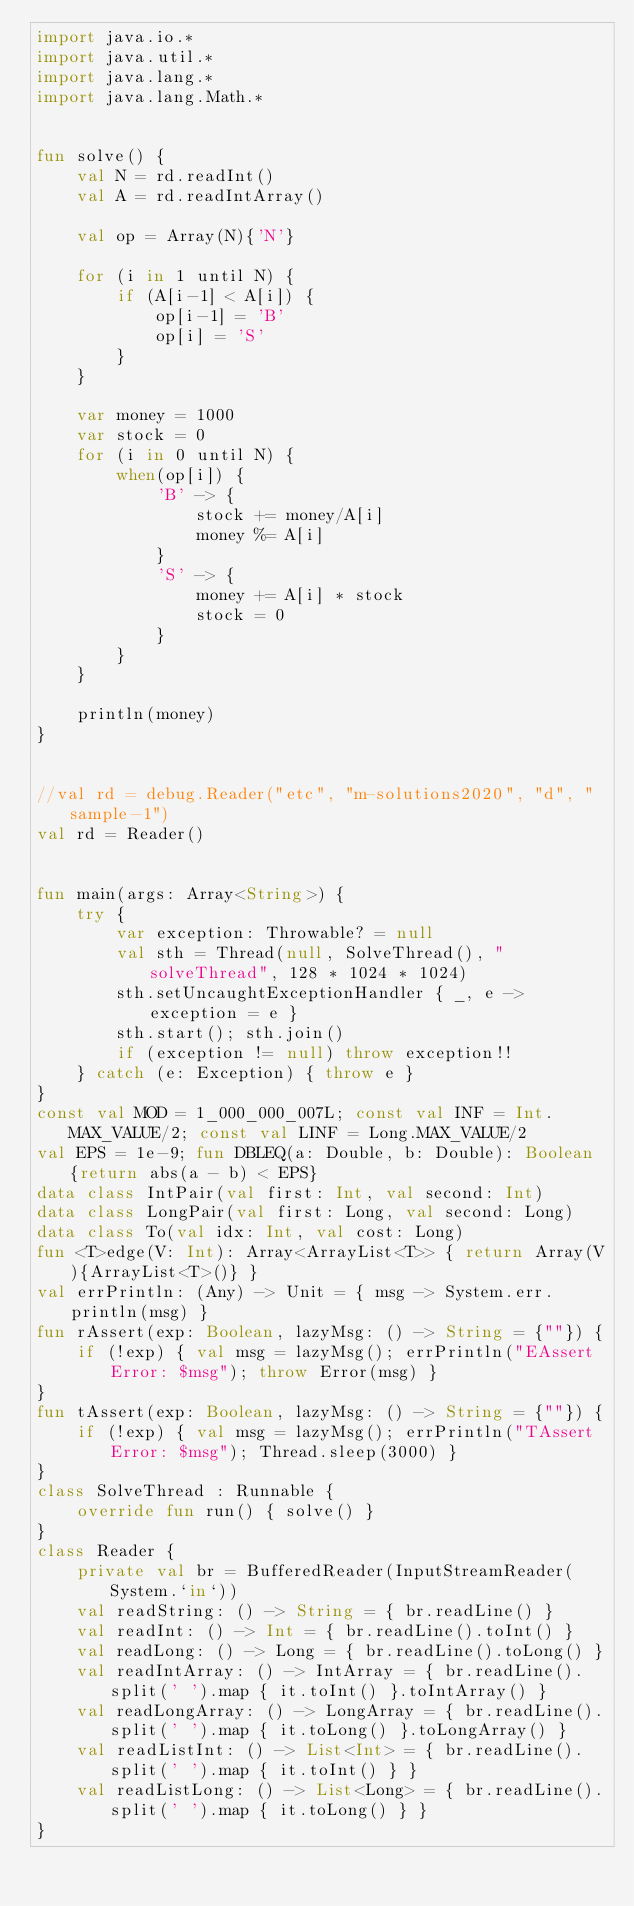<code> <loc_0><loc_0><loc_500><loc_500><_Kotlin_>import java.io.*
import java.util.*
import java.lang.*
import java.lang.Math.*


fun solve() {
    val N = rd.readInt()
    val A = rd.readIntArray()

    val op = Array(N){'N'}

    for (i in 1 until N) {
        if (A[i-1] < A[i]) {
            op[i-1] = 'B'
            op[i] = 'S'
        }
    }

    var money = 1000
    var stock = 0
    for (i in 0 until N) {
        when(op[i]) {
            'B' -> {
                stock += money/A[i]
                money %= A[i]
            }
            'S' -> {
                money += A[i] * stock
                stock = 0
            }
        }
    }

    println(money)
}


//val rd = debug.Reader("etc", "m-solutions2020", "d", "sample-1")
val rd = Reader()


fun main(args: Array<String>) {
    try {
        var exception: Throwable? = null
        val sth = Thread(null, SolveThread(), "solveThread", 128 * 1024 * 1024)
        sth.setUncaughtExceptionHandler { _, e -> exception = e }
        sth.start(); sth.join()
        if (exception != null) throw exception!!
    } catch (e: Exception) { throw e }
}
const val MOD = 1_000_000_007L; const val INF = Int.MAX_VALUE/2; const val LINF = Long.MAX_VALUE/2
val EPS = 1e-9; fun DBLEQ(a: Double, b: Double): Boolean {return abs(a - b) < EPS}
data class IntPair(val first: Int, val second: Int)
data class LongPair(val first: Long, val second: Long)
data class To(val idx: Int, val cost: Long)
fun <T>edge(V: Int): Array<ArrayList<T>> { return Array(V){ArrayList<T>()} }
val errPrintln: (Any) -> Unit = { msg -> System.err.println(msg) }
fun rAssert(exp: Boolean, lazyMsg: () -> String = {""}) {
    if (!exp) { val msg = lazyMsg(); errPrintln("EAssert Error: $msg"); throw Error(msg) }
}
fun tAssert(exp: Boolean, lazyMsg: () -> String = {""}) {
    if (!exp) { val msg = lazyMsg(); errPrintln("TAssert Error: $msg"); Thread.sleep(3000) }
}
class SolveThread : Runnable {
    override fun run() { solve() }
}
class Reader {
    private val br = BufferedReader(InputStreamReader(System.`in`))
    val readString: () -> String = { br.readLine() }
    val readInt: () -> Int = { br.readLine().toInt() }
    val readLong: () -> Long = { br.readLine().toLong() }
    val readIntArray: () -> IntArray = { br.readLine().split(' ').map { it.toInt() }.toIntArray() }
    val readLongArray: () -> LongArray = { br.readLine().split(' ').map { it.toLong() }.toLongArray() }
    val readListInt: () -> List<Int> = { br.readLine().split(' ').map { it.toInt() } }
    val readListLong: () -> List<Long> = { br.readLine().split(' ').map { it.toLong() } }
}
</code> 